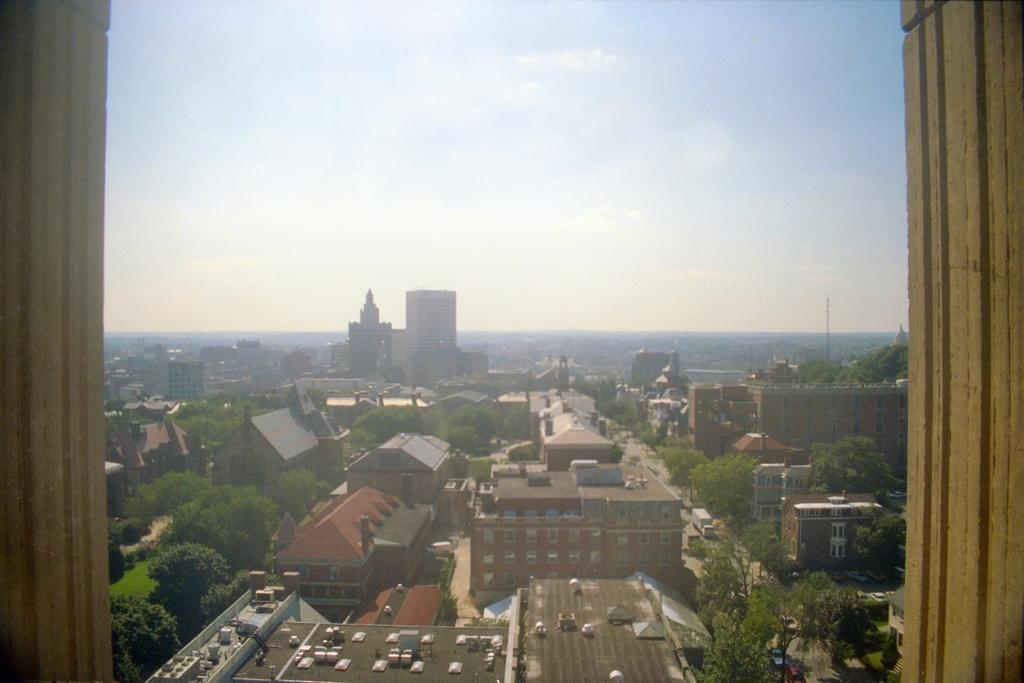Please provide a concise description of this image. In this picture we can see buildings and some objects, here we can see trees and vehicles on the road and we can see sky in the background. 